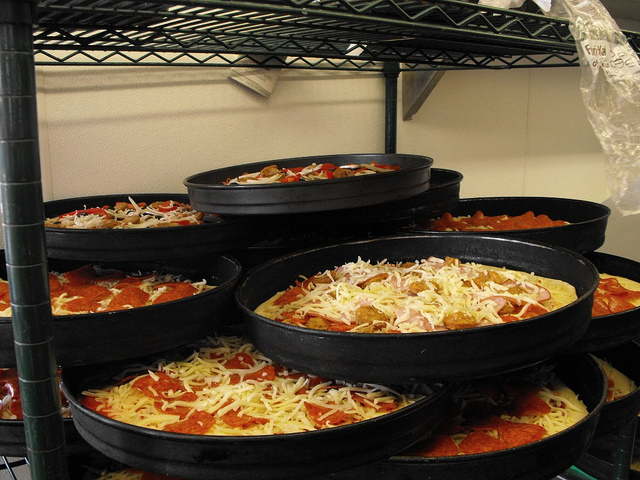Please provide a short description for this region: [0.52, 0.68, 0.95, 0.88]. The region described by the coordinates [0.52, 0.68, 0.95, 0.88] corresponds to a pizza pan located at the bottom-right, loaded with a half-visible pizza rich in cheese and toppings, under preparation or awaiting further cooking. 